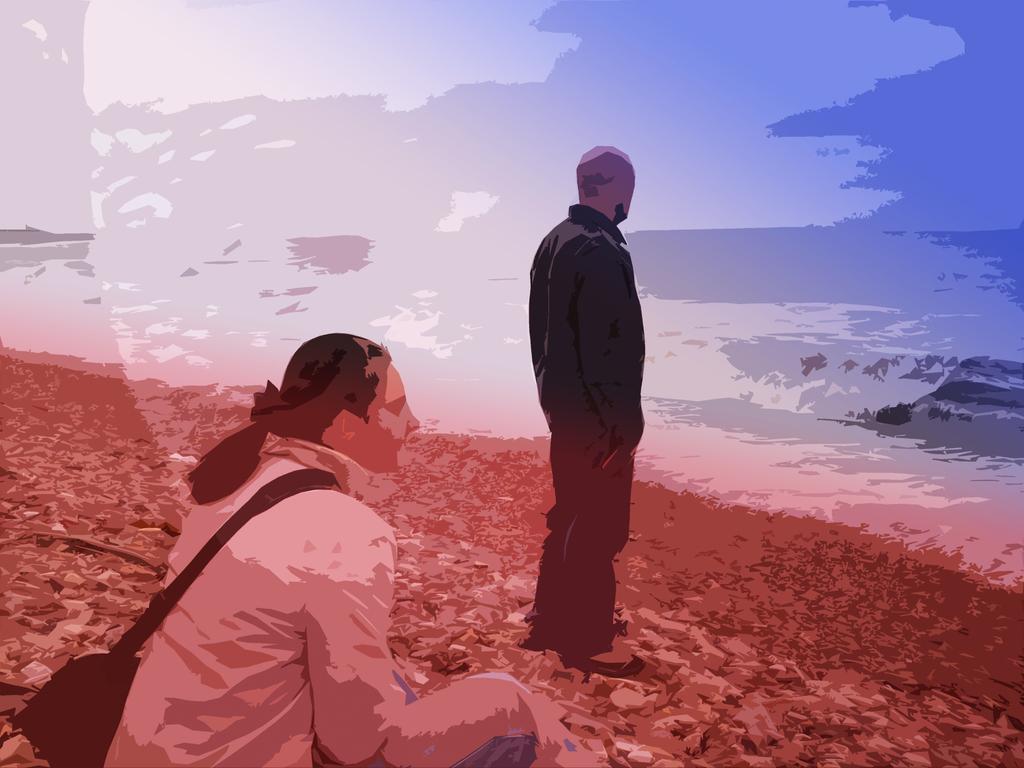Describe this image in one or two sentences. In this image we can see there is a painting of a lady wearing bag and sitting on the surface, in front of her there is a person standing. In the background there is a river and sky. 